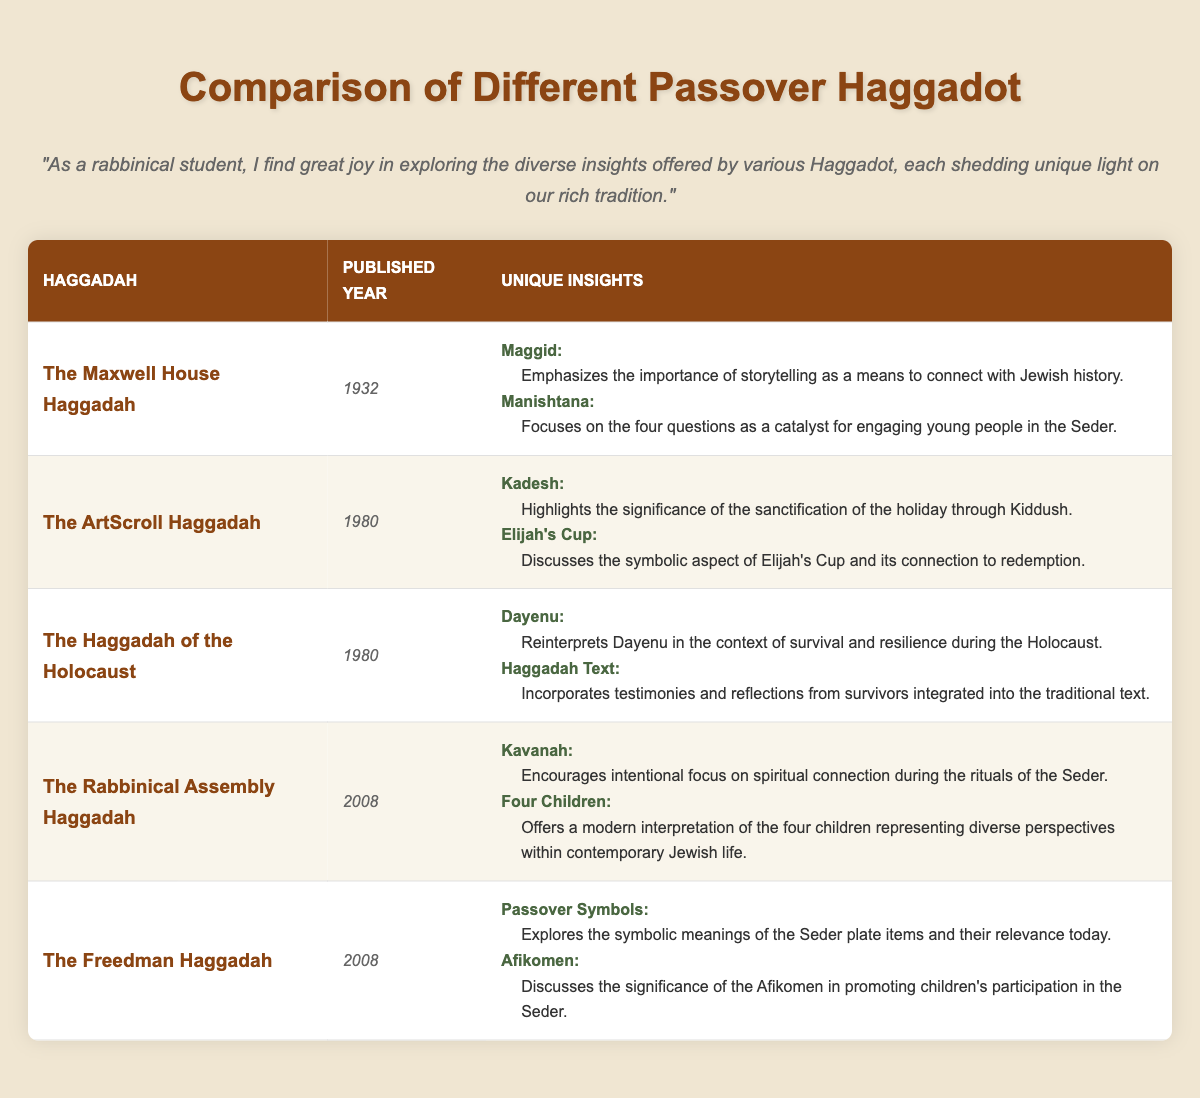What is the published year of The Maxwell House Haggadah? The published year for The Maxwell House Haggadah is listed directly in the table. By looking at the second column for this Haggadah, we find that it is 1932.
Answer: 1932 What unique insight does The ArtScroll Haggadah provide about Elijah's Cup? The table provides insight details under the "Unique Insights" section. For The ArtScroll Haggadah, it states that it discusses the symbolic aspect of Elijah's Cup and its connection to redemption.
Answer: Discusses the symbolic aspect of Elijah's Cup and its connection to redemption How many Haggadot were published in 2008? By reviewing the table, we can see that The Rabbinical Assembly Haggadah and The Freedman Haggadah are the only entries listed with the published year of 2008, which gives us a total of 2 Haggadot.
Answer: 2 Is there a Haggadah that emphasizes storytelling in the Maggid section? The table indicates that The Maxwell House Haggadah uniquely emphasizes the importance of storytelling in the Maggid section. Thus, the answer is yes.
Answer: Yes Which Haggadah offers a modern interpretation of the four children? Referring to the table, we find that The Rabbinical Assembly Haggadah offers a modern interpretation of the four children in its unique insights, specifically in the section titled Four Children.
Answer: The Rabbinical Assembly Haggadah What is the total number of unique insights from The Haggadah of the Holocaust? The insights from The Haggadah of the Holocaust consist of two sections listed: Dayenu and Haggadah Text. Therefore, we can total them to get 2 unique insights for this Haggadah.
Answer: 2 Which Haggadah examines the significance of Passover symbols? Searching the table, we find that The Freedman Haggadah uniquely explores the significance of Passover symbols in the relevant section titled Passover Symbols.
Answer: The Freedman Haggadah How does the approach to the Dayenu section differ between The Maxwell House Haggadah and The Haggadah of the Holocaust? In comparing the two entries, The Maxwell House Haggadah does not mention Dayenu, while The Haggadah of the Holocaust reinterprets Dayenu in the context of survival and resilience. Thus, their approaches are different, with one providing a unique context for the Dayenu text.
Answer: They differ; The Haggadah of the Holocaust reinterprets it in the context of survival and resilience What unique insight does The Freedman Haggadah provide about the Afikomen? The Freedman Haggadah provides insight that discusses the significance of the Afikomen in promoting children’s participation in the Seder. This is directly referenced in the Unique Insights section of the table.
Answer: Discusses the significance of the Afikomen in promoting children’s participation in the Seder 